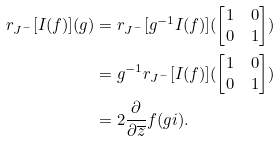Convert formula to latex. <formula><loc_0><loc_0><loc_500><loc_500>r _ { J ^ { - } } [ I ( f ) ] ( g ) & = r _ { J ^ { - } } [ g ^ { - 1 } I ( f ) ] ( \begin{bmatrix} 1 & 0 \\ 0 & 1 \end{bmatrix} ) \\ & = g ^ { - 1 } r _ { J ^ { - } } [ I ( f ) ] ( \begin{bmatrix} 1 & 0 \\ 0 & 1 \end{bmatrix} ) \\ & = 2 \frac { \partial } { \partial \overline { z } } f ( g i ) .</formula> 